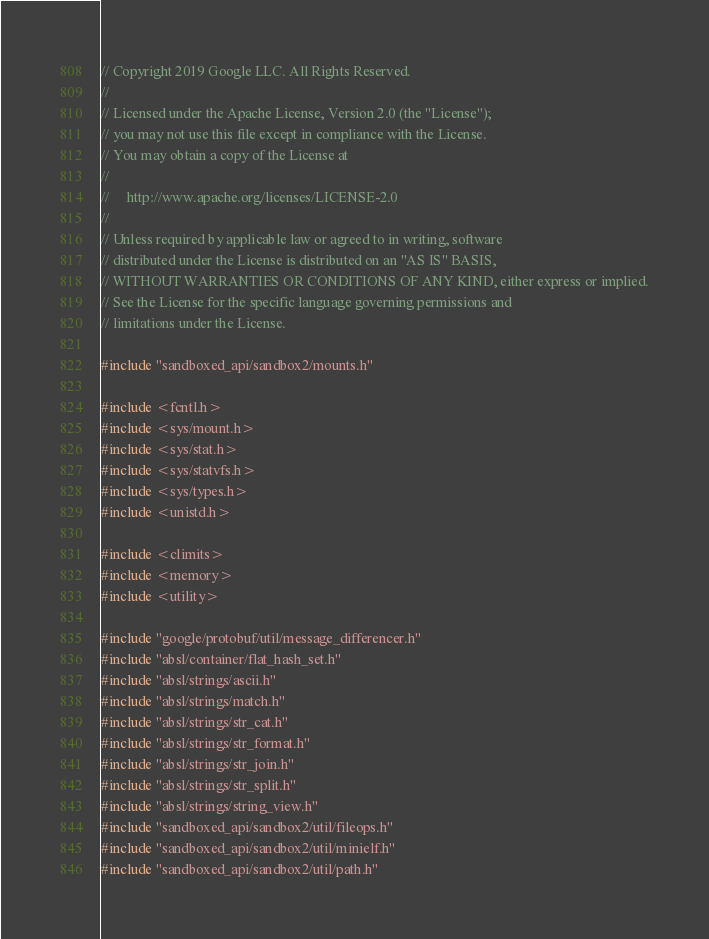<code> <loc_0><loc_0><loc_500><loc_500><_C++_>// Copyright 2019 Google LLC. All Rights Reserved.
//
// Licensed under the Apache License, Version 2.0 (the "License");
// you may not use this file except in compliance with the License.
// You may obtain a copy of the License at
//
//     http://www.apache.org/licenses/LICENSE-2.0
//
// Unless required by applicable law or agreed to in writing, software
// distributed under the License is distributed on an "AS IS" BASIS,
// WITHOUT WARRANTIES OR CONDITIONS OF ANY KIND, either express or implied.
// See the License for the specific language governing permissions and
// limitations under the License.

#include "sandboxed_api/sandbox2/mounts.h"

#include <fcntl.h>
#include <sys/mount.h>
#include <sys/stat.h>
#include <sys/statvfs.h>
#include <sys/types.h>
#include <unistd.h>

#include <climits>
#include <memory>
#include <utility>

#include "google/protobuf/util/message_differencer.h"
#include "absl/container/flat_hash_set.h"
#include "absl/strings/ascii.h"
#include "absl/strings/match.h"
#include "absl/strings/str_cat.h"
#include "absl/strings/str_format.h"
#include "absl/strings/str_join.h"
#include "absl/strings/str_split.h"
#include "absl/strings/string_view.h"
#include "sandboxed_api/sandbox2/util/fileops.h"
#include "sandboxed_api/sandbox2/util/minielf.h"
#include "sandboxed_api/sandbox2/util/path.h"</code> 